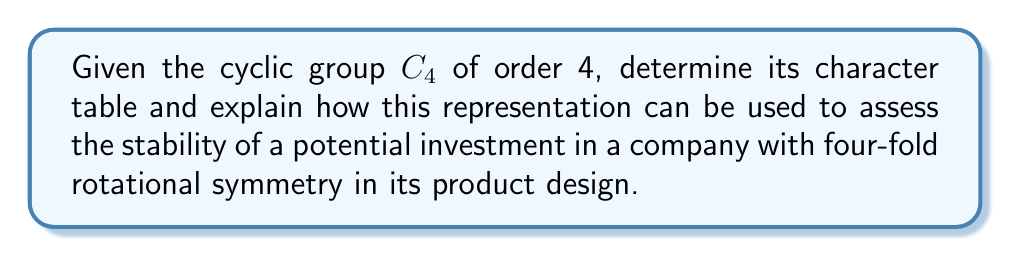Help me with this question. 1. First, let's identify the elements of $C_4$:
   $C_4 = \{e, g, g^2, g^3\}$, where $e$ is the identity and $g$ is a generator.

2. The number of irreducible representations equals the number of conjugacy classes. For $C_4$, each element is in its own conjugacy class, so there are 4 irreducible representations.

3. The character table will be a 4x4 matrix. Let's label the rows as $\chi_1, \chi_2, \chi_3, \chi_4$.

4. $\chi_1$ is always the trivial representation, giving 1 for all elements:
   $\chi_1: 1, 1, 1, 1$

5. For the other representations, we use the formula $\chi_j(g^k) = \omega^{jk}$, where $\omega = e^{2\pi i/4} = i$.

6. This gives us:
   $\chi_2: 1, i, -1, -i$
   $\chi_3: 1, -1, 1, -1$
   $\chi_4: 1, -i, -1, i$

7. The complete character table is:

   $$
   \begin{array}{c|cccc}
    C_4 & e & g & g^2 & g^3 \\
    \hline
    \chi_1 & 1 & 1 & 1 & 1 \\
    \chi_2 & 1 & i & -1 & -i \\
    \chi_3 & 1 & -1 & 1 & -1 \\
    \chi_4 & 1 & -i & -1 & i
   \end{array}
   $$

8. To assess investment stability:
   - The trivial representation $\chi_1$ indicates overall market stability.
   - $\chi_2$ and $\chi_4$ represent cyclical behavior with 4 phases, useful for seasonal trends.
   - $\chi_3$ shows a two-phase alternation, indicating potential binary market states.

9. A company with four-fold rotational symmetry in its product design may have market performance that aligns with these representations, allowing for more accurate risk assessment and forecasting.
Answer: Character table of $C_4$:
$$
\begin{array}{c|cccc}
C_4 & e & g & g^2 & g^3 \\
\hline
\chi_1 & 1 & 1 & 1 & 1 \\
\chi_2 & 1 & i & -1 & -i \\
\chi_3 & 1 & -1 & 1 & -1 \\
\chi_4 & 1 & -i & -1 & i
\end{array}
$$ 